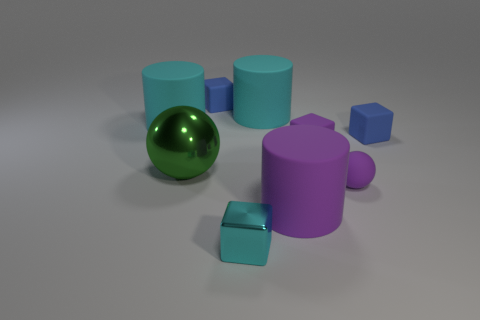Subtract all gray cubes. Subtract all green cylinders. How many cubes are left? 4 Add 1 small cyan metal objects. How many objects exist? 10 Subtract all blocks. How many objects are left? 5 Add 5 spheres. How many spheres are left? 7 Add 6 large green spheres. How many large green spheres exist? 7 Subtract 0 blue balls. How many objects are left? 9 Subtract all tiny purple rubber blocks. Subtract all big green shiny spheres. How many objects are left? 7 